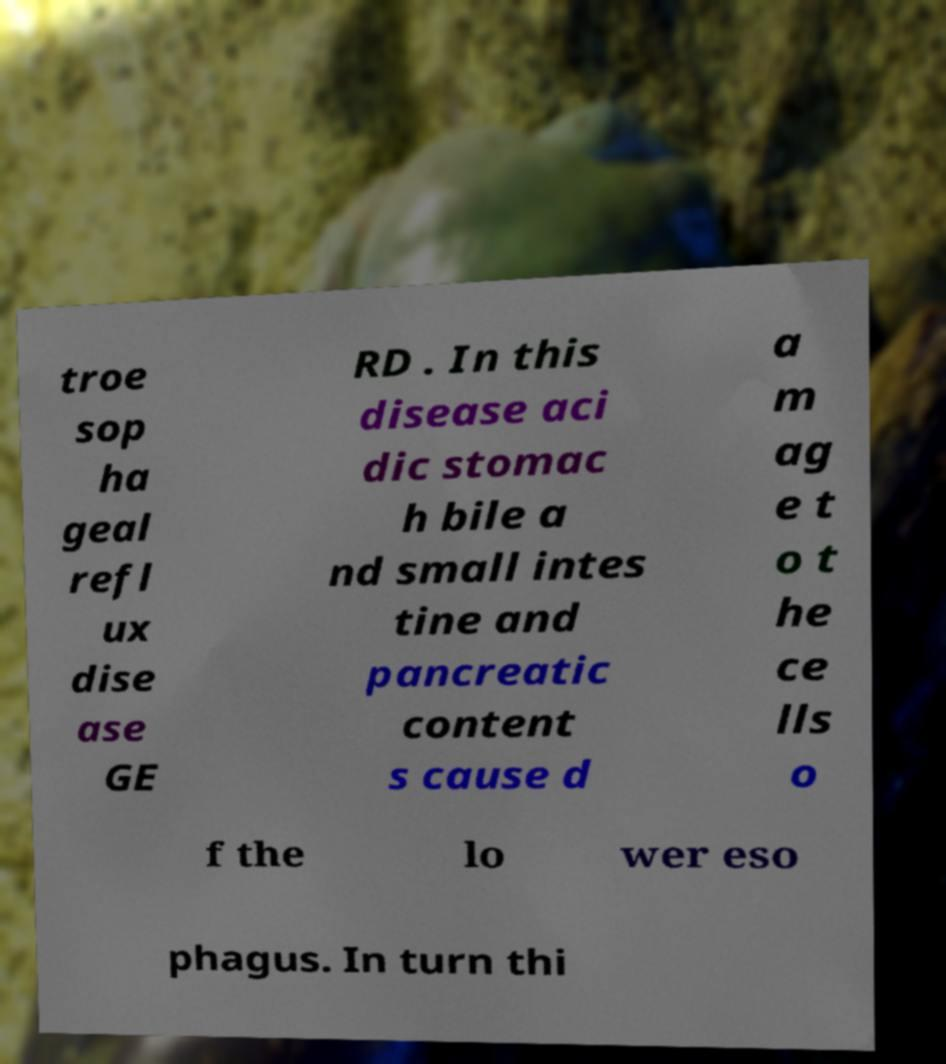Please identify and transcribe the text found in this image. troe sop ha geal refl ux dise ase GE RD . In this disease aci dic stomac h bile a nd small intes tine and pancreatic content s cause d a m ag e t o t he ce lls o f the lo wer eso phagus. In turn thi 